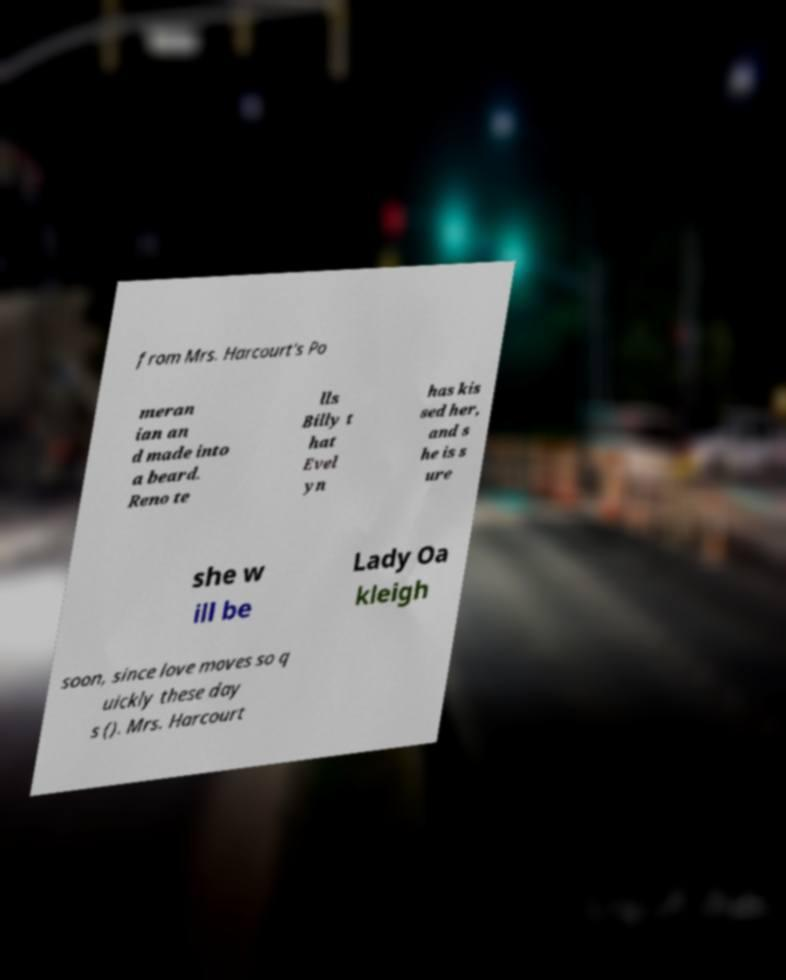Please read and relay the text visible in this image. What does it say? from Mrs. Harcourt's Po meran ian an d made into a beard. Reno te lls Billy t hat Evel yn has kis sed her, and s he is s ure she w ill be Lady Oa kleigh soon, since love moves so q uickly these day s (). Mrs. Harcourt 